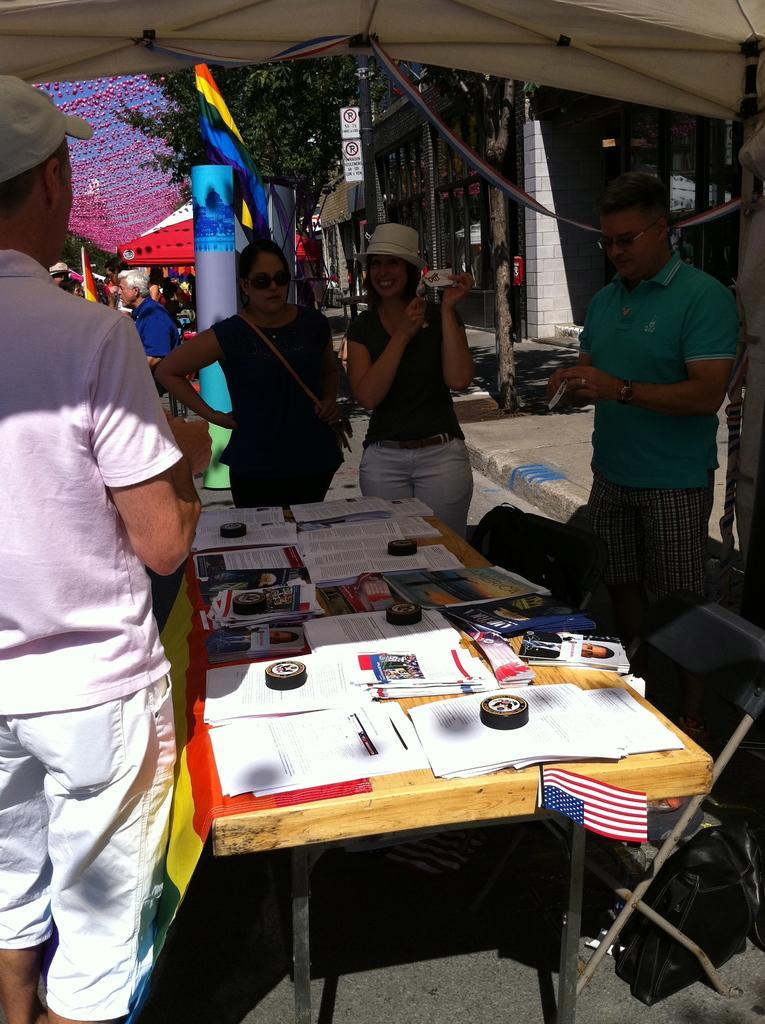Please provide a concise description of this image. In this image, few peoples are standing near the table. So many items are placed on the table. right side, we can see chairs. In the middle, woman is wearing hat on his head ,she is smiling. On left side, a person is wearing a cap. There is a flag and trees, buildings, board are placed in the middle we can see. We can see some still here, few peoples are there. 